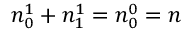Convert formula to latex. <formula><loc_0><loc_0><loc_500><loc_500>n _ { 0 } ^ { 1 } + n _ { 1 } ^ { 1 } = n _ { 0 } ^ { 0 } = n</formula> 